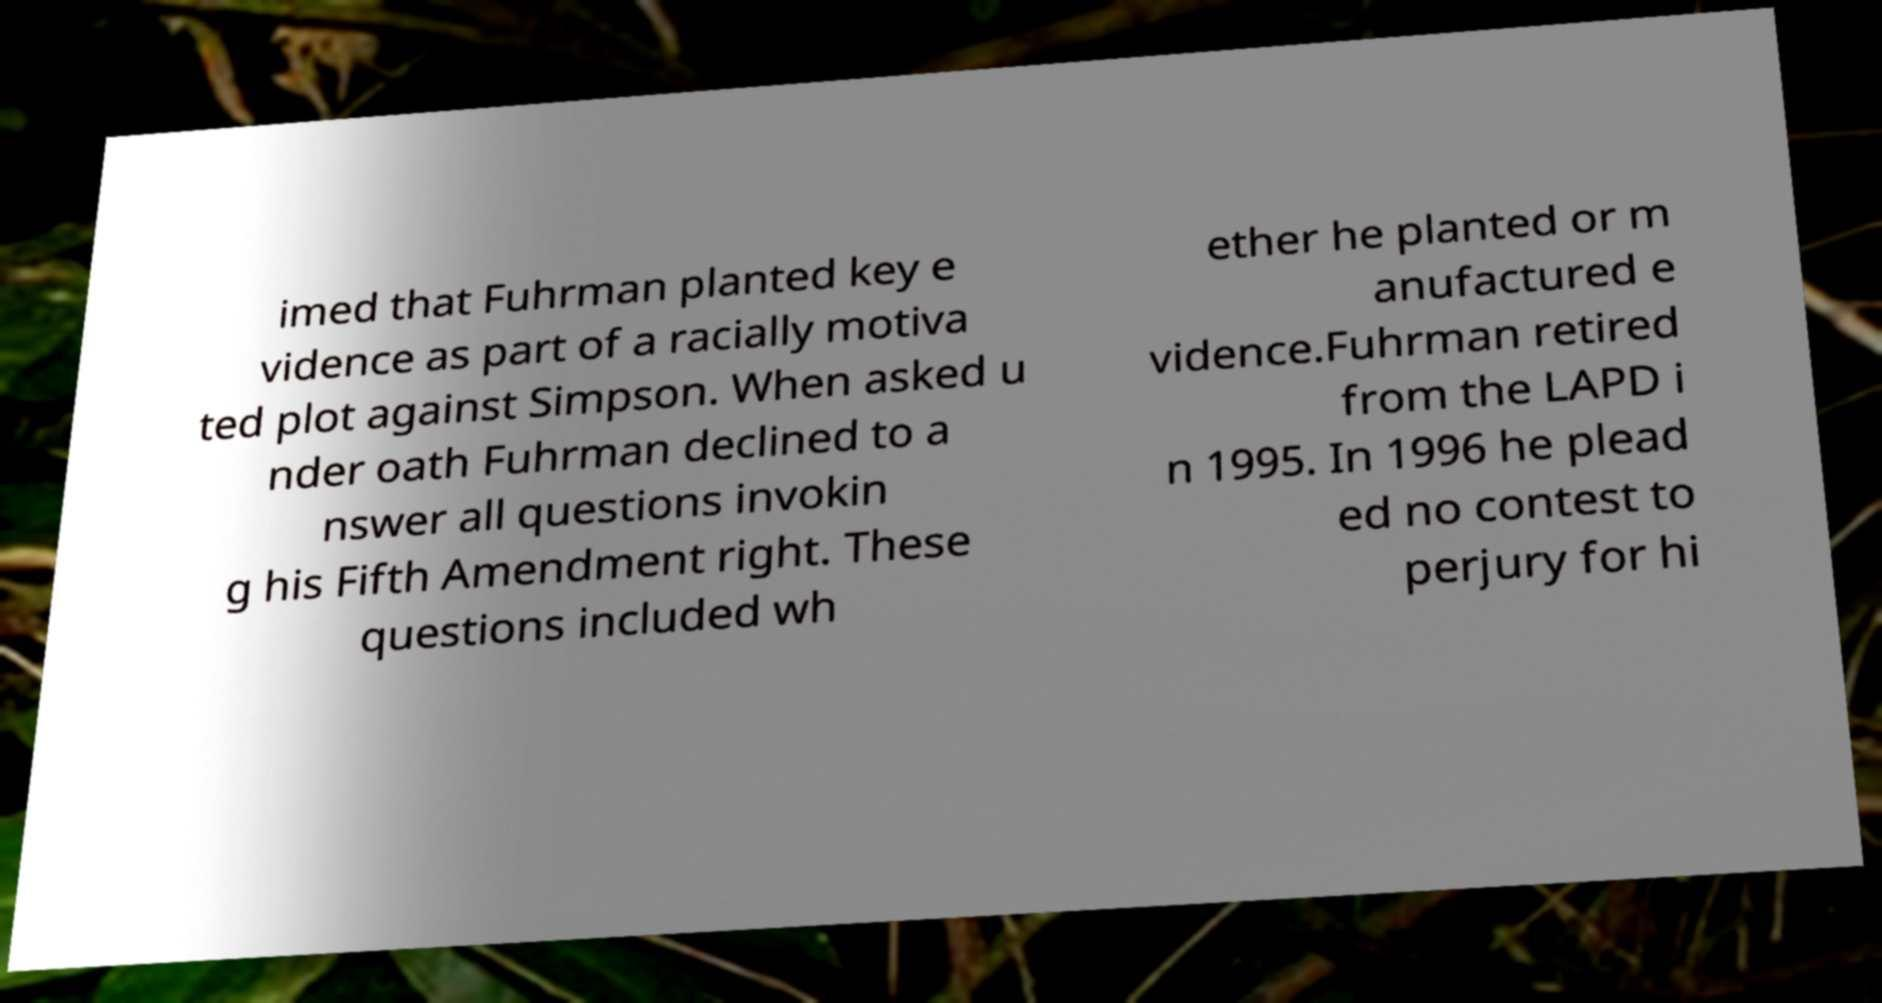For documentation purposes, I need the text within this image transcribed. Could you provide that? imed that Fuhrman planted key e vidence as part of a racially motiva ted plot against Simpson. When asked u nder oath Fuhrman declined to a nswer all questions invokin g his Fifth Amendment right. These questions included wh ether he planted or m anufactured e vidence.Fuhrman retired from the LAPD i n 1995. In 1996 he plead ed no contest to perjury for hi 